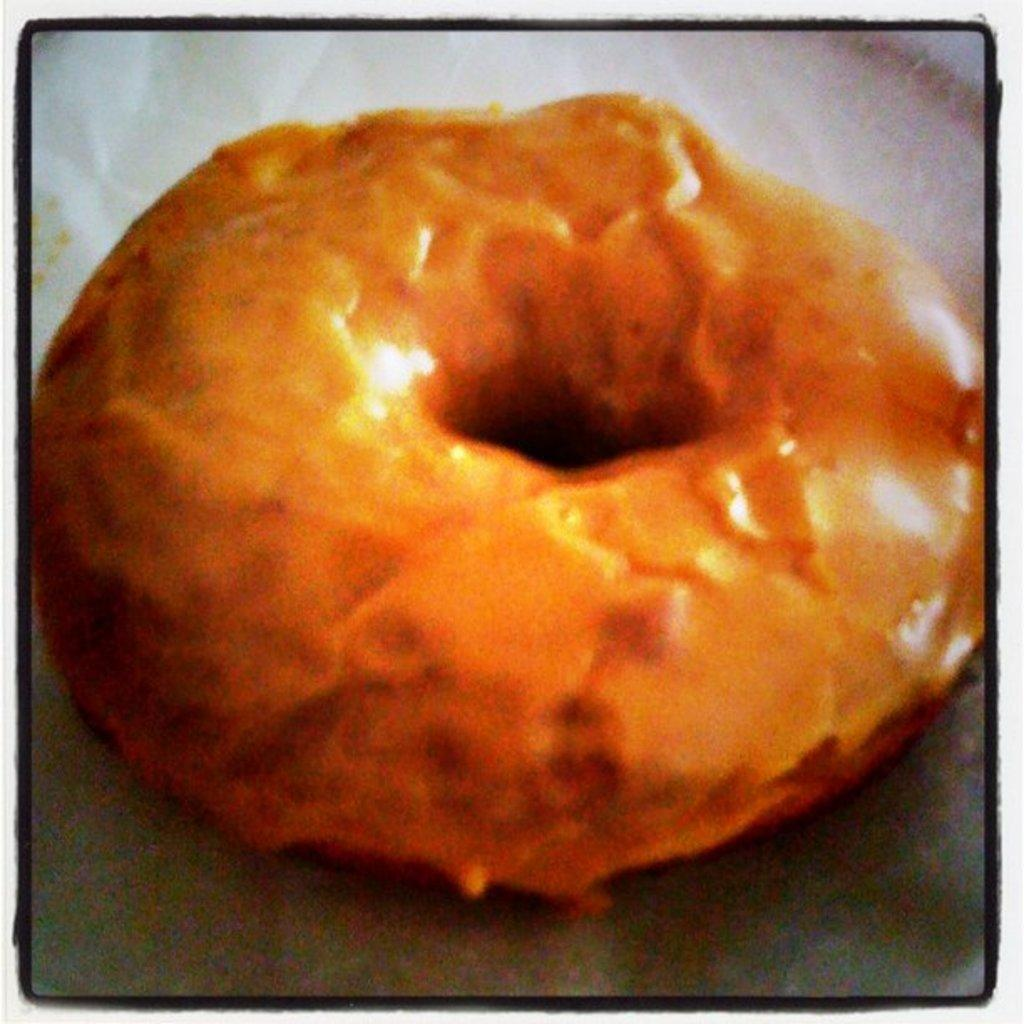What is the main subject of the image? There is a food item in the image. Where is the food item located? The food item is on a platform. What type of education does the carpenter in the image have? There is no carpenter present in the image, so it is not possible to determine their education. 